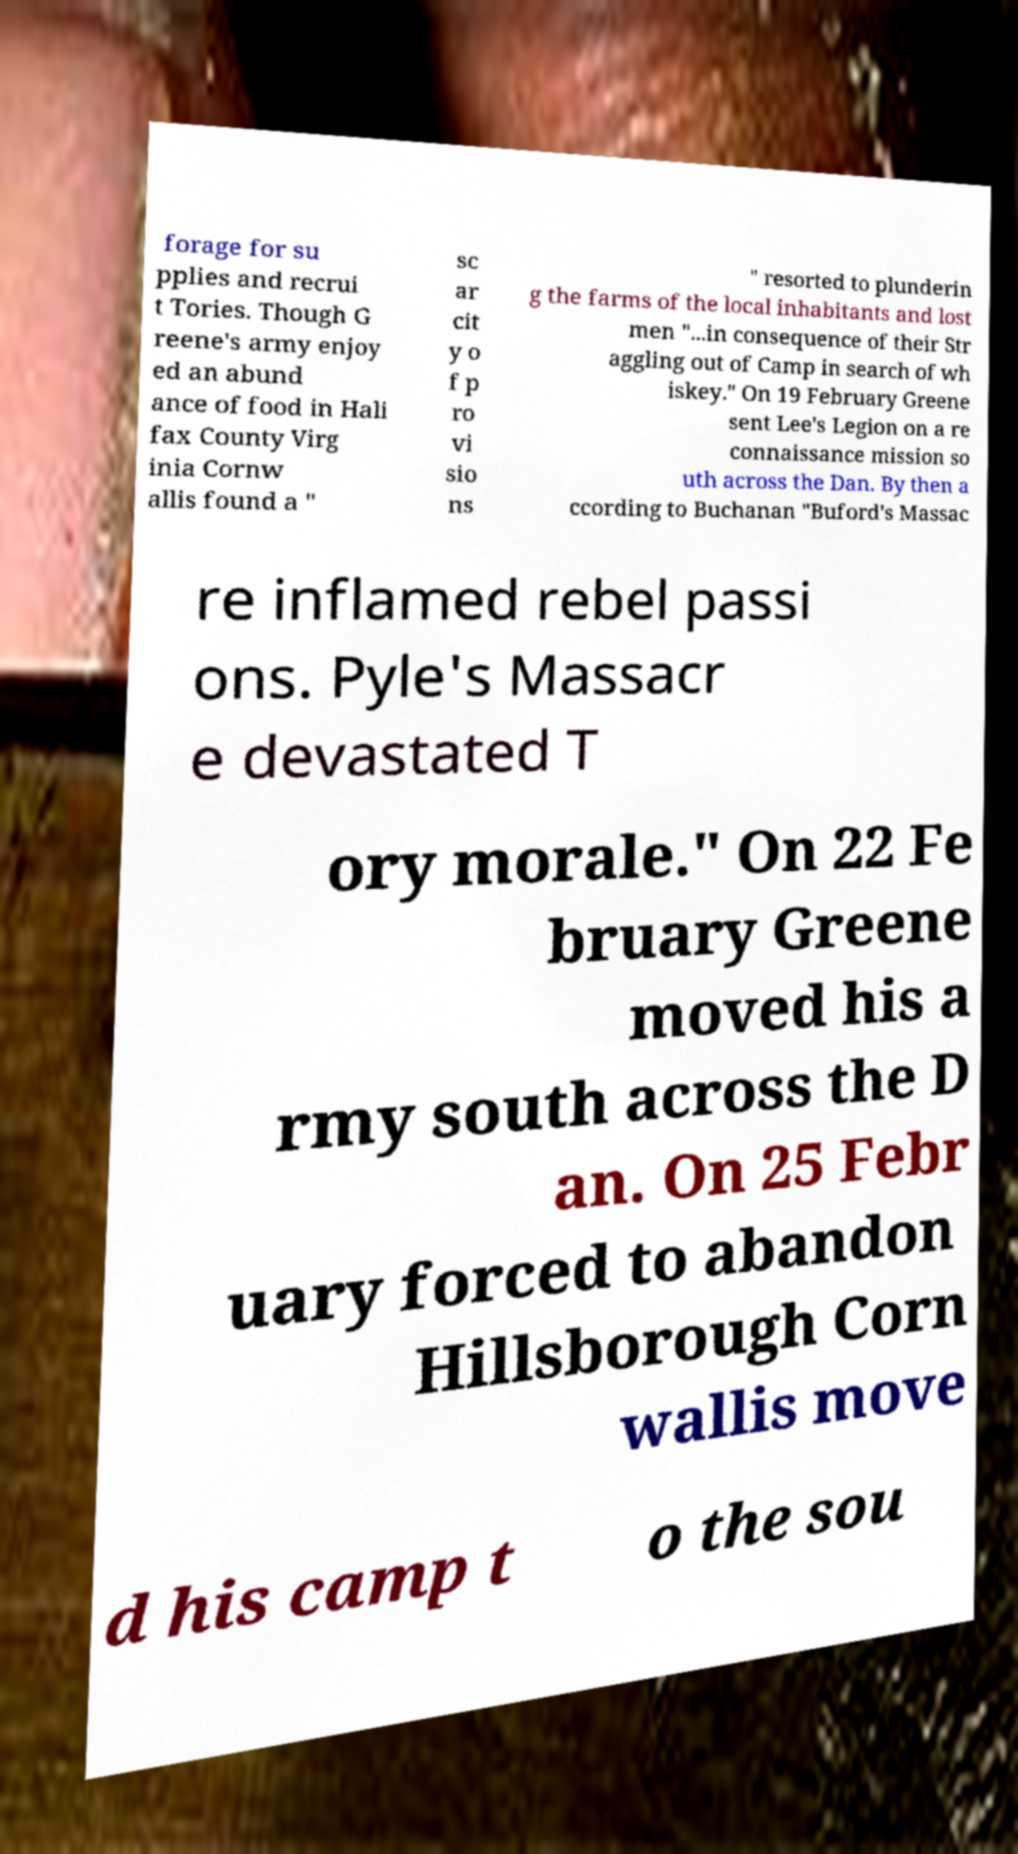Please read and relay the text visible in this image. What does it say? forage for su pplies and recrui t Tories. Though G reene's army enjoy ed an abund ance of food in Hali fax County Virg inia Cornw allis found a " sc ar cit y o f p ro vi sio ns " resorted to plunderin g the farms of the local inhabitants and lost men "...in consequence of their Str aggling out of Camp in search of wh iskey." On 19 February Greene sent Lee's Legion on a re connaissance mission so uth across the Dan. By then a ccording to Buchanan "Buford's Massac re inflamed rebel passi ons. Pyle's Massacr e devastated T ory morale." On 22 Fe bruary Greene moved his a rmy south across the D an. On 25 Febr uary forced to abandon Hillsborough Corn wallis move d his camp t o the sou 